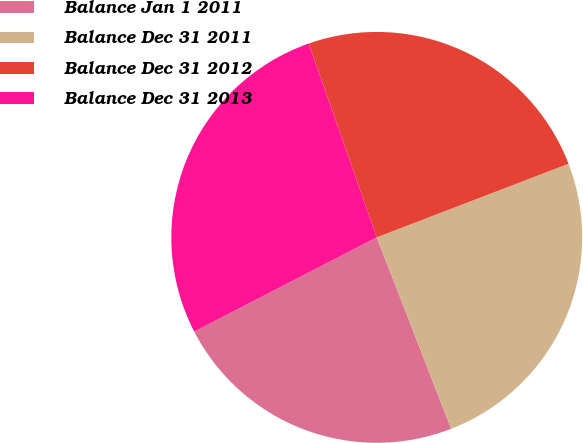Convert chart to OTSL. <chart><loc_0><loc_0><loc_500><loc_500><pie_chart><fcel>Balance Jan 1 2011<fcel>Balance Dec 31 2011<fcel>Balance Dec 31 2012<fcel>Balance Dec 31 2013<nl><fcel>23.32%<fcel>24.93%<fcel>24.54%<fcel>27.21%<nl></chart> 